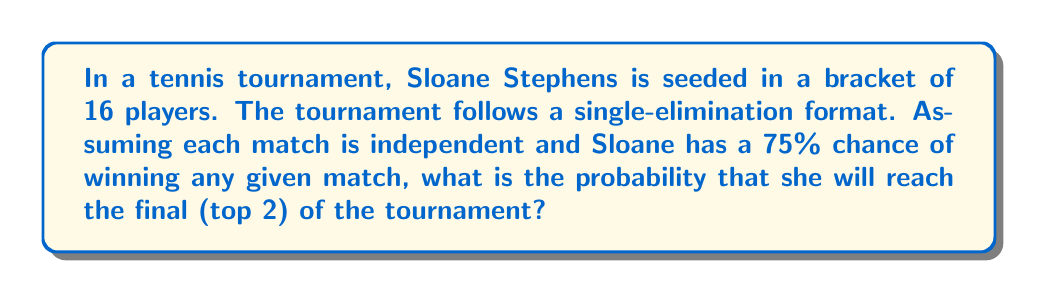Show me your answer to this math problem. Let's approach this step-by-step:

1) In a bracket of 16 players, a player needs to win 3 matches to reach the final.

2) For Sloane to reach the final, she needs to win her first match AND her second match AND her third match.

3) The probability of winning each match is 75% or 0.75.

4) Since the matches are independent, we can use the multiplication rule of probability.

5) The probability of Sloane reaching the final is:

   $$P(\text{reaching final}) = P(\text{win 1st}) \times P(\text{win 2nd}) \times P(\text{win 3rd})$$

6) Substituting the probabilities:

   $$P(\text{reaching final}) = 0.75 \times 0.75 \times 0.75$$

7) Calculating:

   $$P(\text{reaching final}) = 0.75^3 = 0.421875$$

Therefore, the probability of Sloane Stephens reaching the final of the tournament is approximately 0.421875 or 42.19%.
Answer: $0.421875$ or $42.19\%$ 